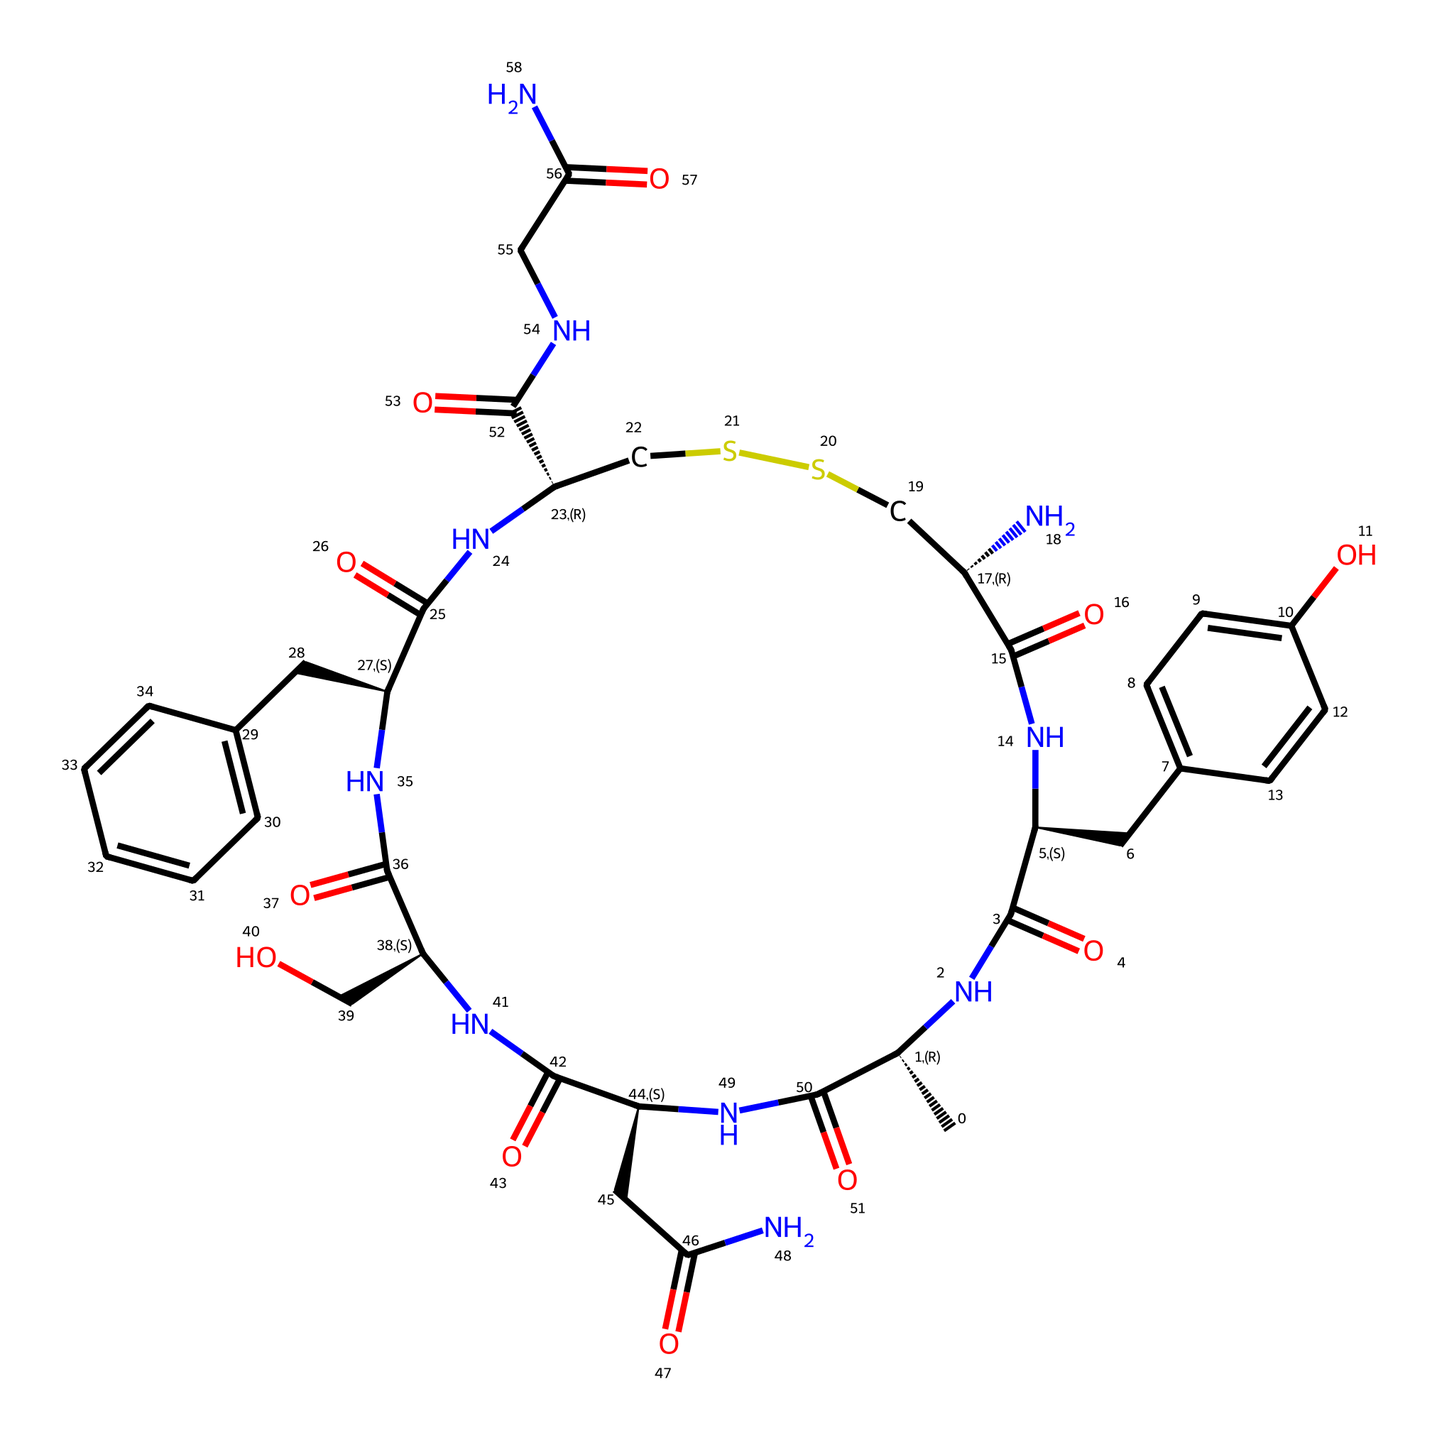What is the primary functional group in this chemical structure? The primary functional group is the amide group, which can be identified by the presence of -C(=O)N- sections throughout the structure. This indicates the presence of nitrogen bonded to a carbonyl carbon, characteristic of amides.
Answer: amide How many rings are present in this molecule? The chemical structure contains two aromatic rings, as evidenced by the CC and C=CC connections that illustrate cyclic arrangements of carbon atoms within aromatic systems.
Answer: two What type of hormone is represented by this structure? This structure represents a peptide hormone due to the presence of amino acids connected through peptide bonds and the arrangement of various side chains, characteristic of peptides.
Answer: peptide Which part of the molecule is likely responsible for emotional bonding? The presence of oxytocin, which is known as the bonding hormone, suggests the entire molecule is designed for emotional connections, particularly the central portion containing amide bonds that affect bonding interactions.
Answer: entire molecule How many nitrogen atoms are in this chemical structure? The structure has six nitrogen atoms, observable through the various -N- and amide (>C(=O)N-) parts integrated into the arrangement of the molecule. Each depicts the inclusion of nitrogen as part of amide or amine functional groups.
Answer: six What is the total number of carbon atoms in the structure? By counting the carbon (C) symbols in the SMILES representation, we find there are 27 carbon atoms present in the structure.
Answer: twenty-seven 